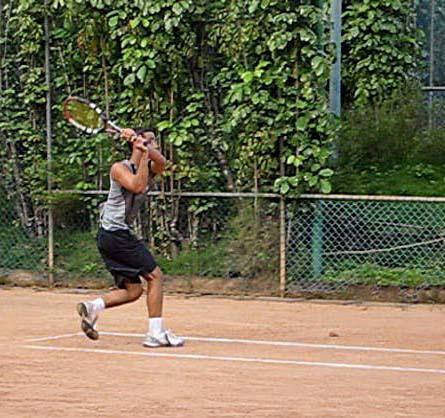How many people?
Give a very brief answer. 1. How many bananas doe the guy have in his back pocket?
Give a very brief answer. 0. 